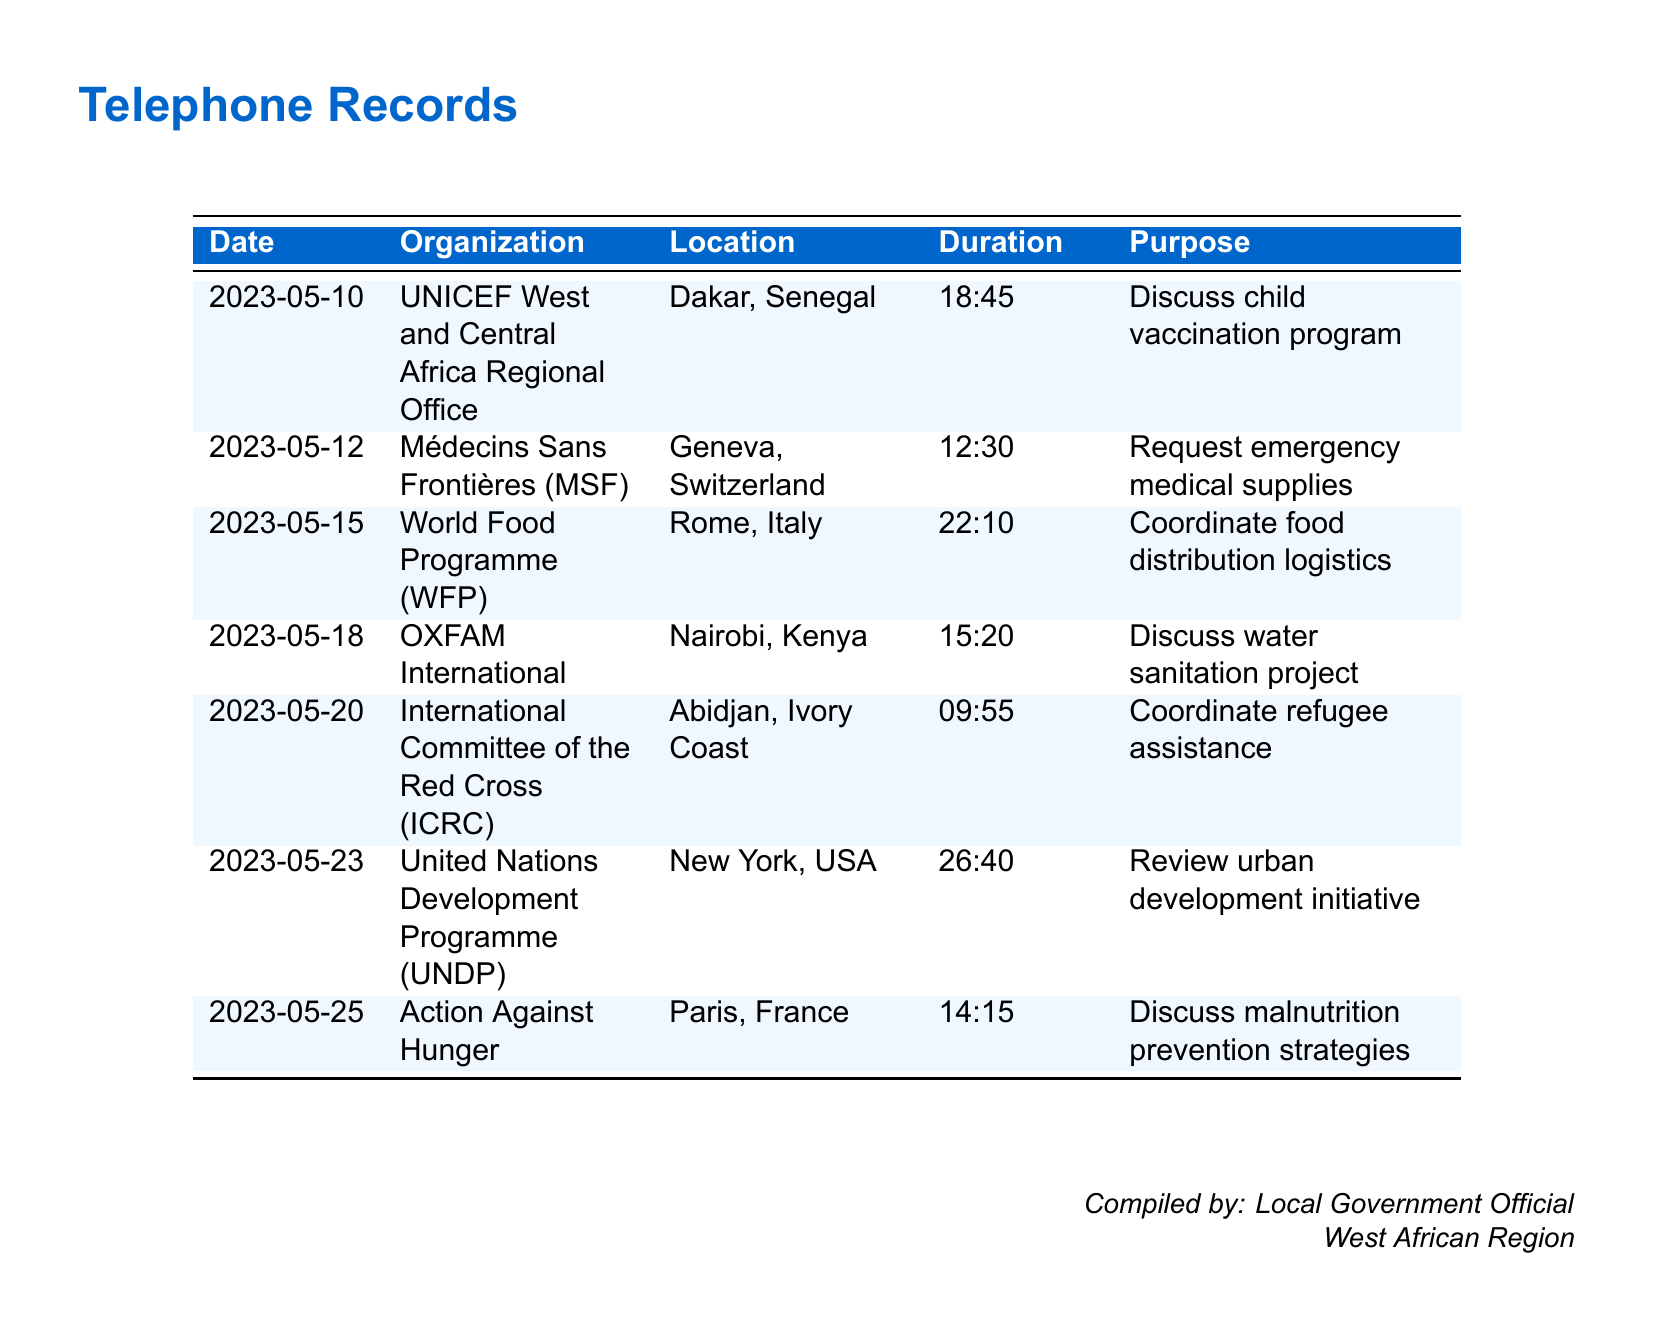What is the date of the call to UNICEF? The date of the call to UNICEF is mentioned in the first row of the table.
Answer: 2023-05-10 How long was the call to the World Food Programme? The duration of the call to the World Food Programme is noted in the third row of the table.
Answer: 22:10 Which organization was contacted for emergency medical supplies? The organization that was contacted for emergency medical supplies is specified in the second row.
Answer: Médecins Sans Frontières (MSF) What was the purpose of the call to OXFAM International? The purpose of the call to OXFAM International is detailed in the fourth row of the table.
Answer: Discuss water sanitation project How many calls were made in May 2023? The total number of calls made in May 2023 can be counted from the rows listed in the document.
Answer: 7 Which organization is located in Geneva? The organization that is located in Geneva is included in the second row of the table.
Answer: Médecins Sans Frontières (MSF) What is the main topic discussed in the call to the International Committee of the Red Cross? The main topic discussed in the call to the International Committee of the Red Cross is mentioned in the fifth row.
Answer: Coordinate refugee assistance Identify the organization related to child vaccination. The organization related to child vaccination is stated in the first row.
Answer: UNICEF West and Central Africa Regional Office What city did the call to the United Nations Development Programme originate from? The location from which the call to the United Nations Development Programme was made is specified in the sixth row.
Answer: New York, USA 